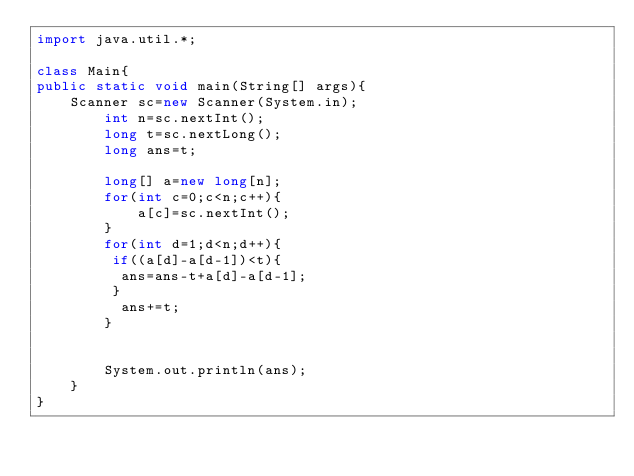<code> <loc_0><loc_0><loc_500><loc_500><_Java_>import java.util.*; 

class Main{
public static void main(String[] args){
	Scanner sc=new Scanner(System.in);
        int n=sc.nextInt();
        long t=sc.nextLong();
  		long ans=t;

  		long[] a=new long[n];
		for(int c=0;c<n;c++){
    		a[c]=sc.nextInt();
    	}
  		for(int d=1;d<n;d++){
         if((a[d]-a[d-1])<t){
          ans=ans-t+a[d]-a[d-1];
         }
          ans+=t;
        }
    
 	
    	System.out.println(ans);
    }
}
</code> 